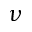Convert formula to latex. <formula><loc_0><loc_0><loc_500><loc_500>\nu</formula> 